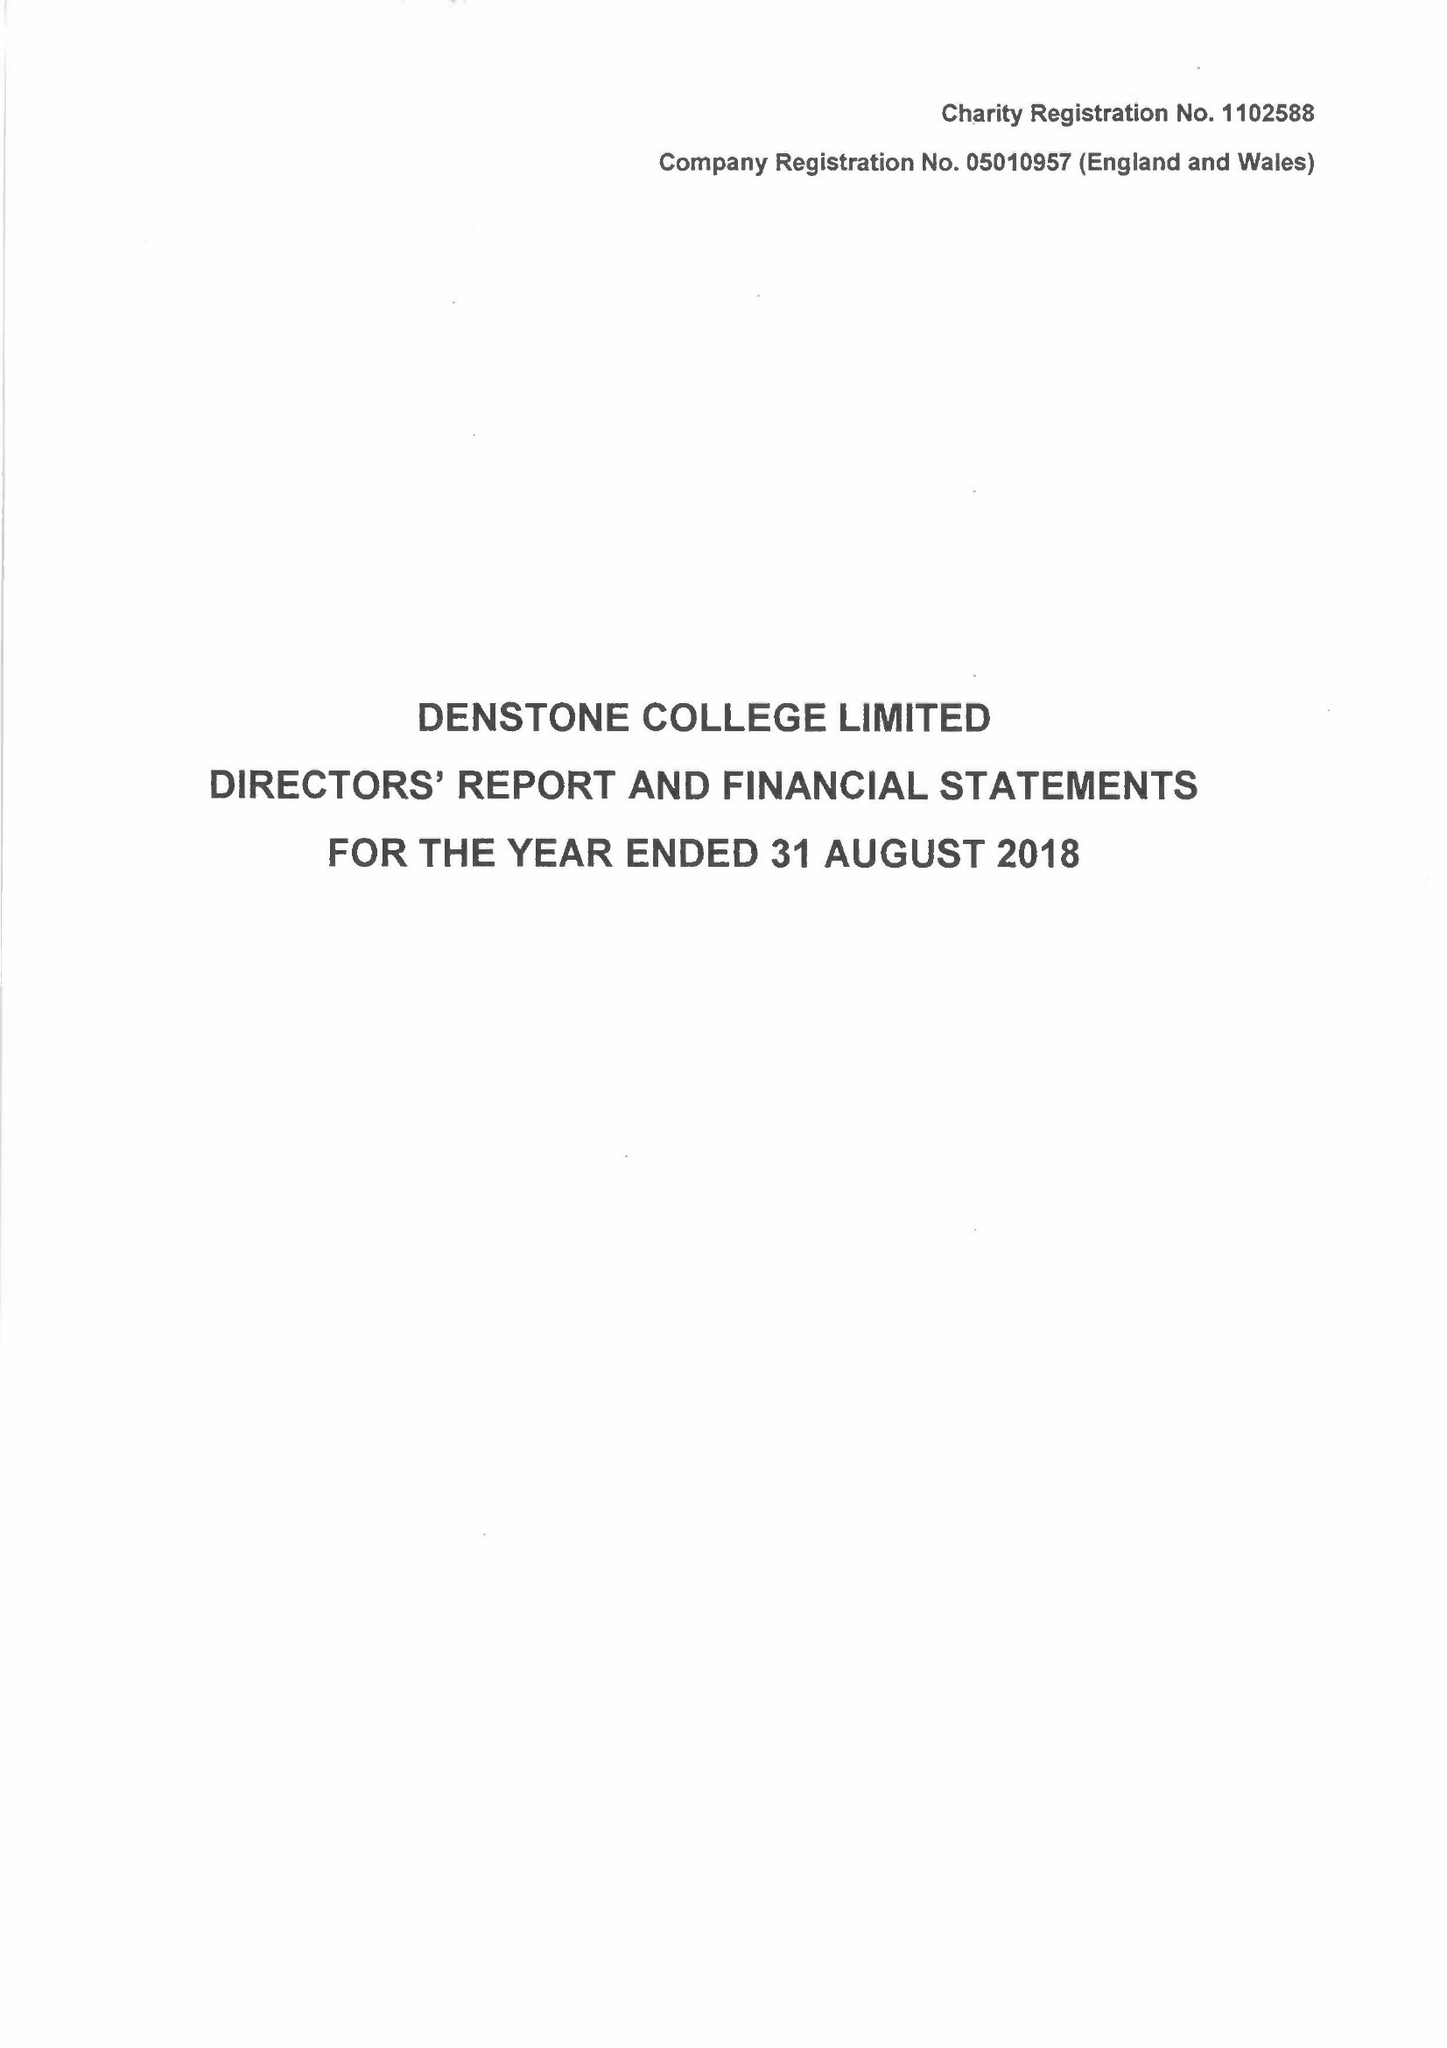What is the value for the address__postcode?
Answer the question using a single word or phrase. ST14 5HN 